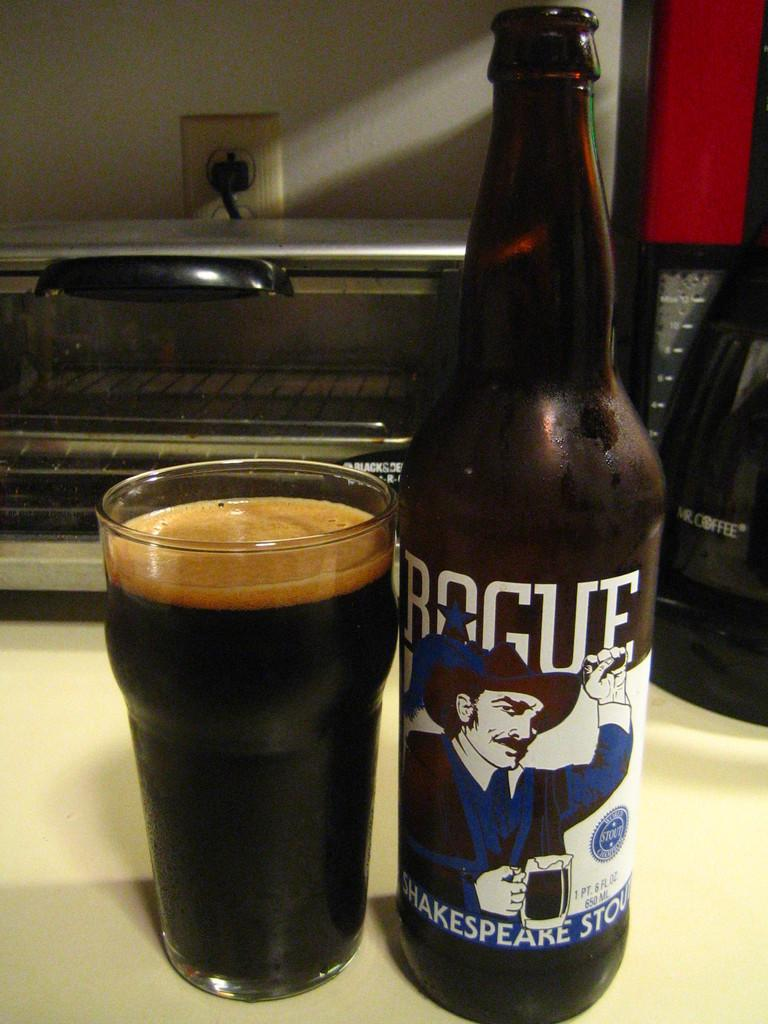<image>
Present a compact description of the photo's key features. Glass of dark beer and a bottle with Rogue Shakespeare Stout. 